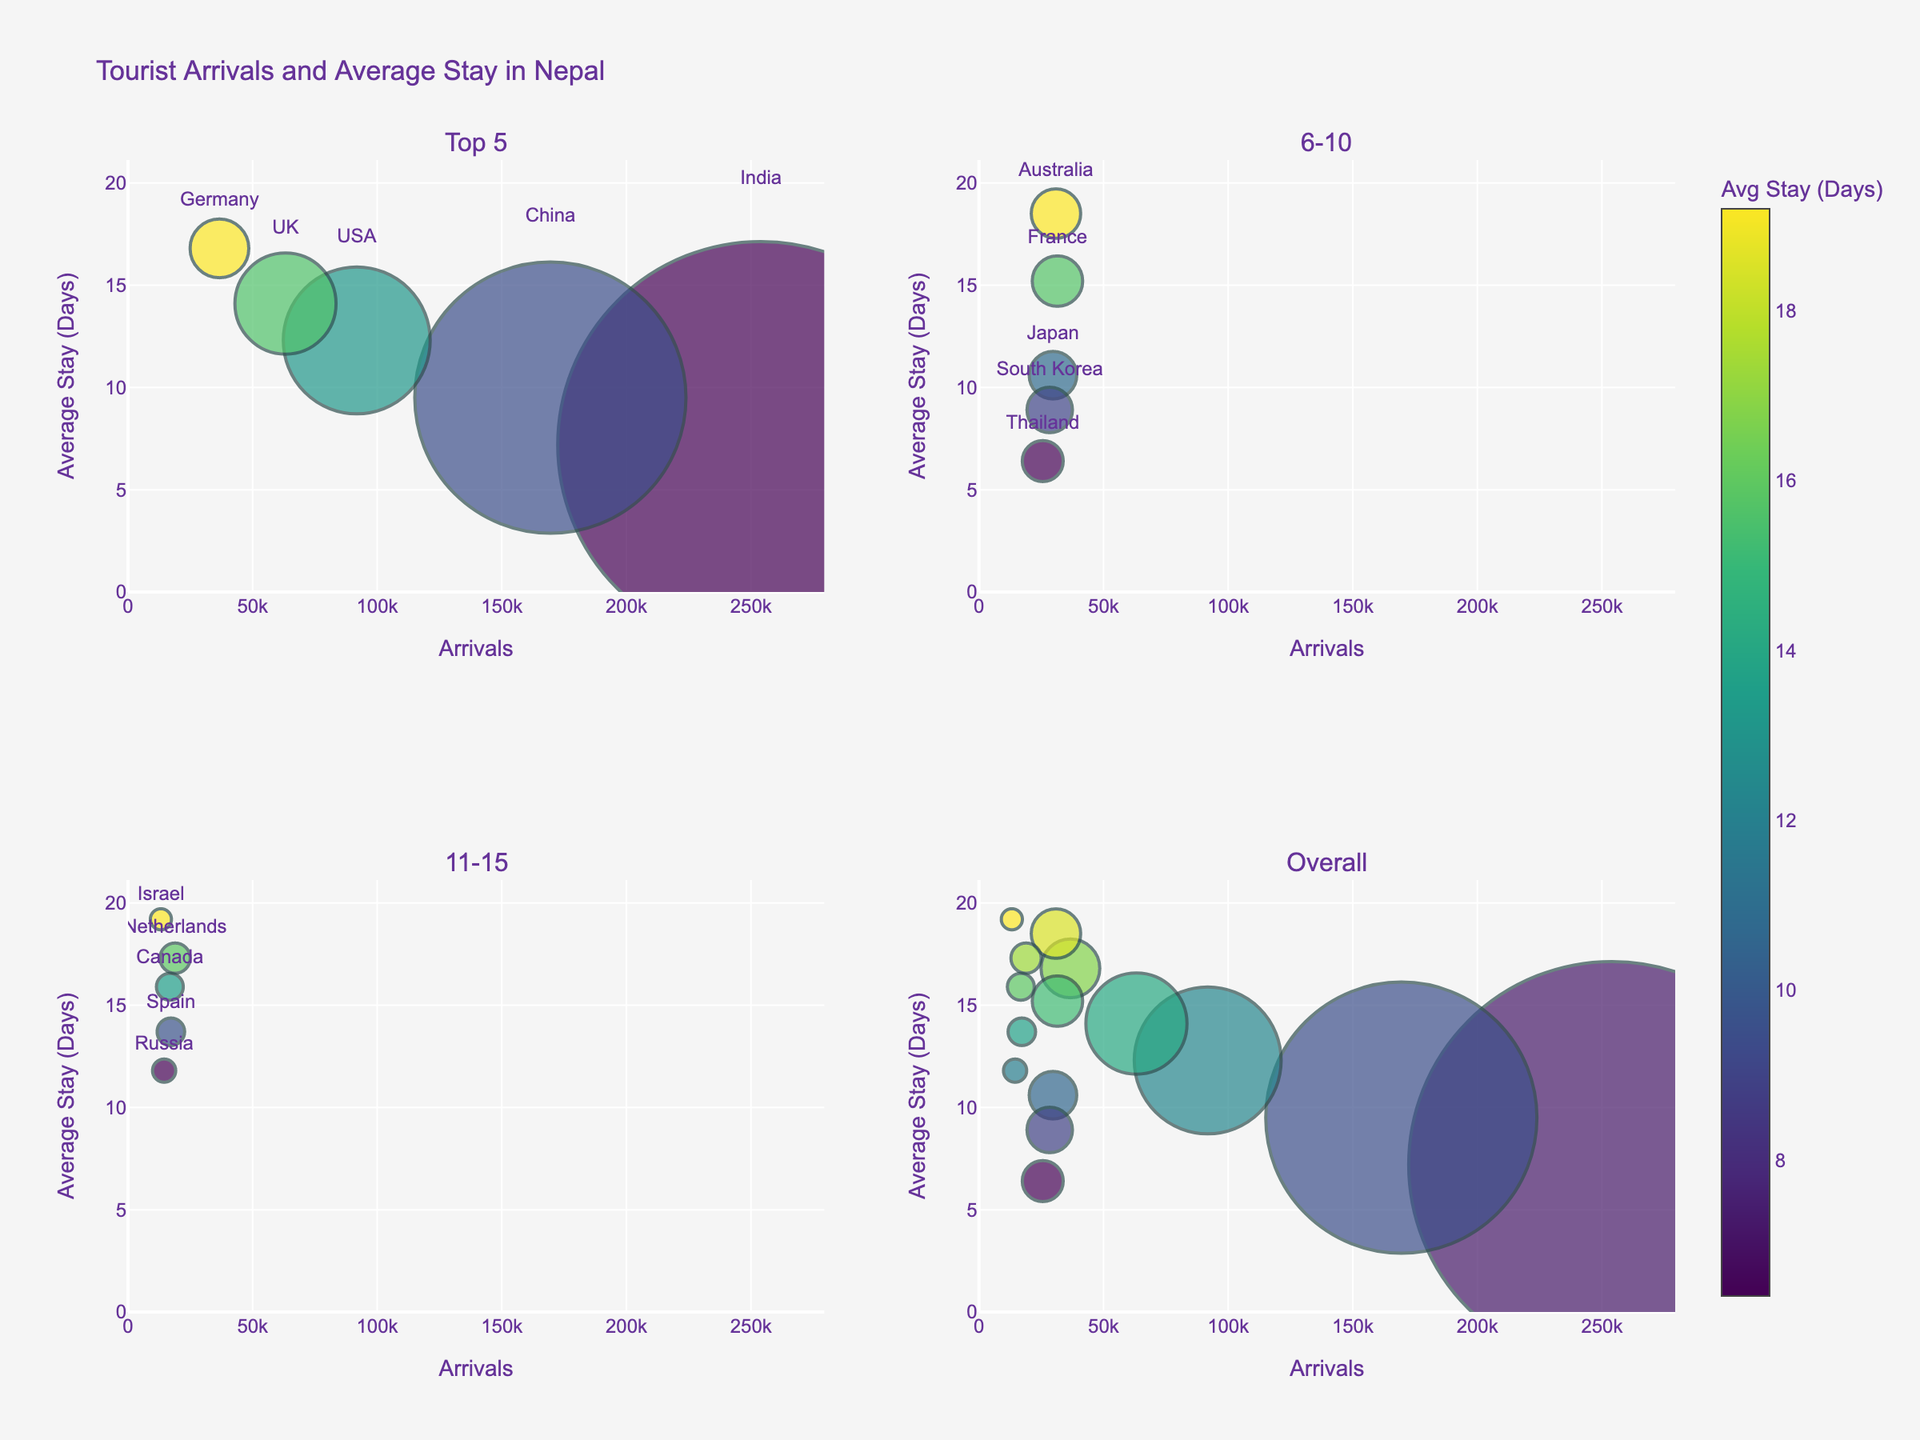What is the average length of stay for tourists from Australia? Locate the bubble representing Australia in the figure and read the hover text or the y-axis value to find the average length of stay.
Answer: 18.5 days Which country has the highest number of tourist arrivals? Identify the largest bubble based on size or check the x-axis value with the highest number of arrivals.
Answer: India How does the length of stay for tourists from France compare to those from Germany? Find the bubbles for France and Germany and compare their positions on the y-axis (average stay). France has a shorter average stay compared to Germany.
Answer: France's stay is shorter What can you say about the relationship between the number of arrivals and the average stay days for the top 5 countries? Examine the bubbles in the "Top 5" subplot for any patterns. Generally, there's no clear trend; higher arrivals don't necessarily mean longer stays. For instance, India has the most arrivals but a shorter average stay, while Germany has fewer arrivals with a longer average stay.
Answer: No clear trend Which country among the top 10 has the shortest average length of stay? Find the bubbles in the "Top 10" subplots and identify the bubble with the lowest value on the y-axis.
Answer: Thailand Compare the average stay of tourists from Canada and Spain. Which is higher and by how much? Locate the bubbles for Canada and Spain and compare their y-axis positions. Canada's average stay is 2.2 days more than Spain's.
Answer: Canada by 2.2 days What is the range of the average stay days for tourists from the bottom 5 countries listed in the data? Identify the bubbles for the bottom 5 countries and note the range by finding the difference between the highest and lowest values on the y-axis. Israel has the highest at 19.2 days and Russia the lowest at 11.8 days, resulting in a range of 7.4 days.
Answer: 7.4 days How many countries have an average length of stay greater than 15 days? Count the bubbles in the figure with y-axis values (average stay) exceeding 15 days. There are six such countries: Germany, France, Australia, Netherlands, Spain, and Israel.
Answer: 6 countries 